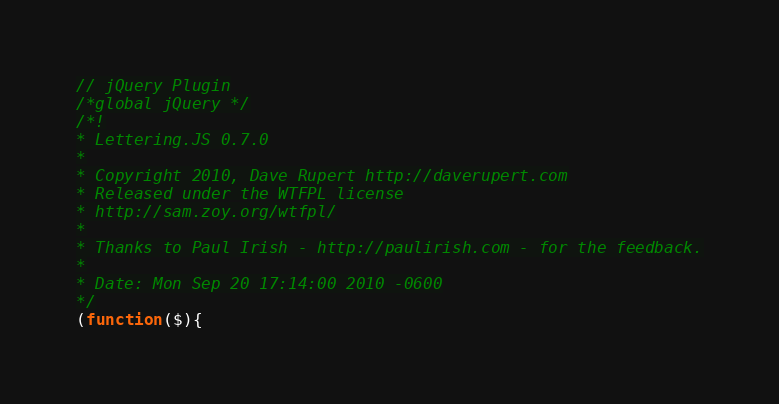<code> <loc_0><loc_0><loc_500><loc_500><_JavaScript_>// jQuery Plugin
/*global jQuery */
/*!
* Lettering.JS 0.7.0
*
* Copyright 2010, Dave Rupert http://daverupert.com
* Released under the WTFPL license
* http://sam.zoy.org/wtfpl/
*
* Thanks to Paul Irish - http://paulirish.com - for the feedback.
*
* Date: Mon Sep 20 17:14:00 2010 -0600
*/
(function($){</code> 